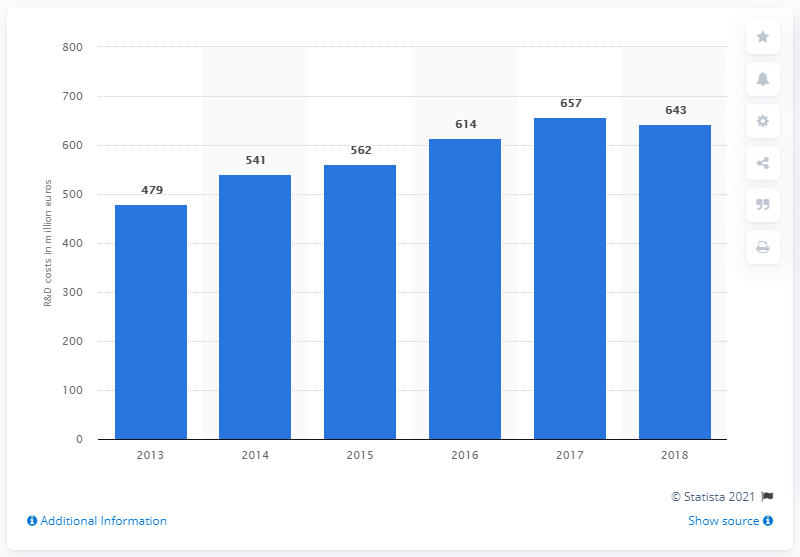Point out several critical features in this image. The sum of the leftmost and the rightmost bars is 1122. In 2018, there was a change in R&D costs that was less than zero. Ferrari's R&D expenditure in 2017 was 657 million. In 2018, Ferrari invested a significant amount in research and development, specifically 643.. 